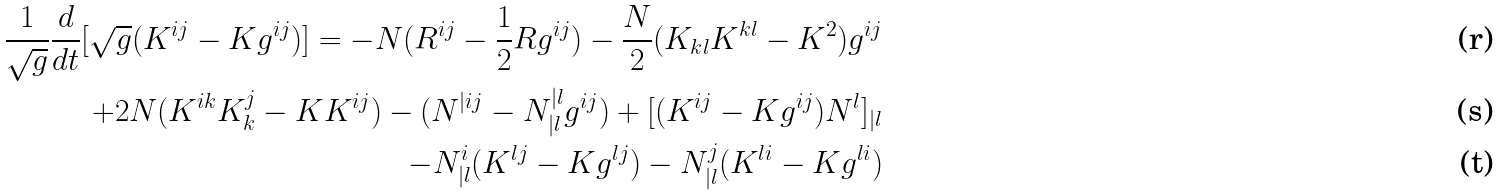Convert formula to latex. <formula><loc_0><loc_0><loc_500><loc_500>\frac { 1 } { \sqrt { g } } \frac { d } { d t } [ \sqrt { g } ( K ^ { i j } - K g ^ { i j } ) ] = - N ( R ^ { i j } - \frac { 1 } { 2 } R g ^ { i j } ) - \frac { N } { 2 } ( K _ { k l } K ^ { k l } - K ^ { 2 } ) g ^ { i j } \\ + 2 N ( K ^ { i k } K ^ { j } _ { k } - K K ^ { i j } ) - ( N ^ { | i j } - N ^ { | l } _ { | l } g ^ { i j } ) + [ ( K ^ { i j } - K g ^ { i j } ) N ^ { l } ] _ { | l } \\ - N ^ { i } _ { | l } ( K ^ { l j } - K g ^ { l j } ) - N ^ { j } _ { | l } ( K ^ { l i } - K g ^ { l i } )</formula> 